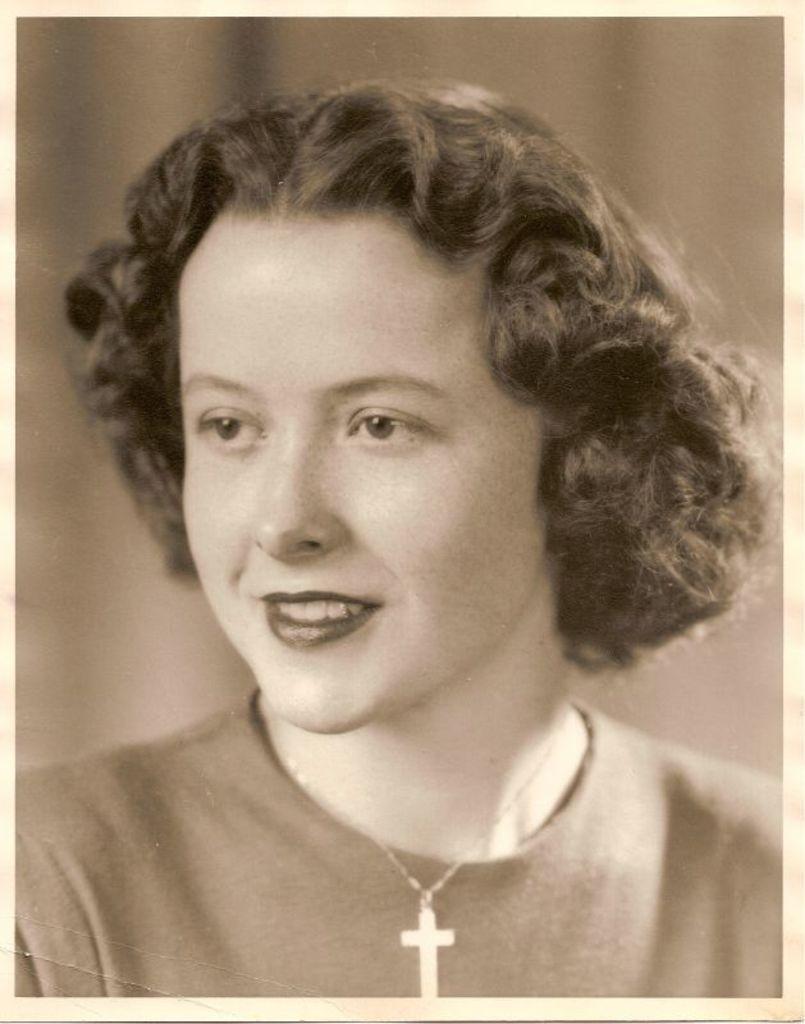Could you give a brief overview of what you see in this image? In the foreground of this image, there is a woman with short hair and she is wearing a T shirt and the cross symbol locket. 